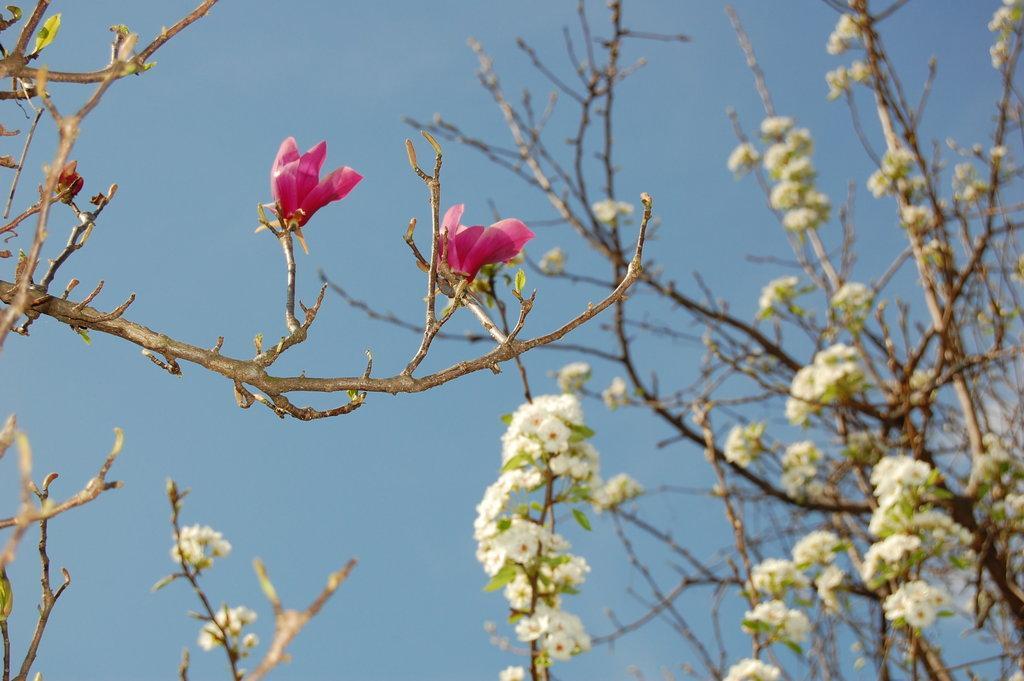In one or two sentences, can you explain what this image depicts? In this image we pink color flowers to the tree. Here the image is slightly blurred, where we can see flowers to the tree and blue sky in the background. 